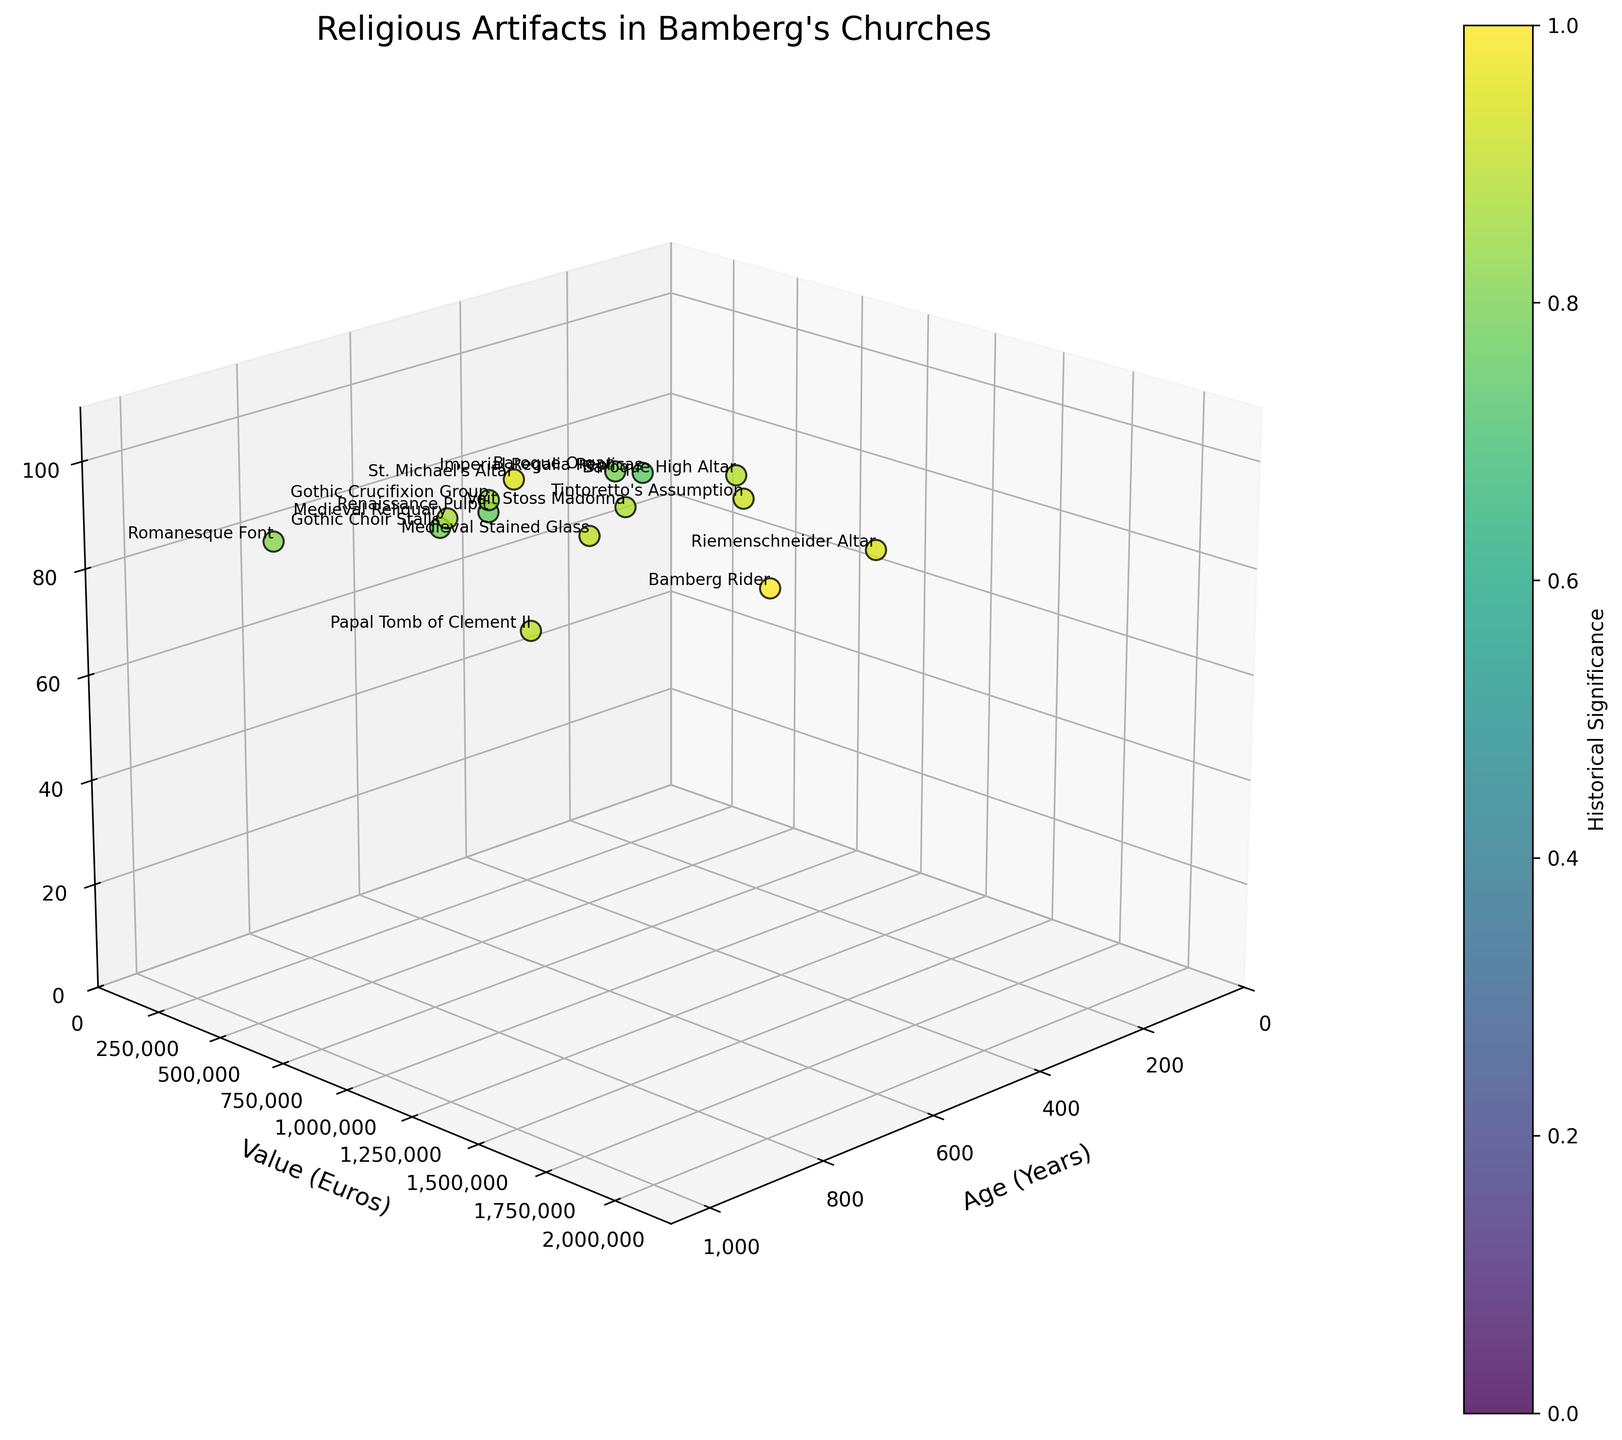what is the title of the figure? The title of the figure is displayed prominently at the top of the plot.
Answer: Religious Artifacts in Bamberg's Churches how many artifacts are displayed in the figure? To determine the number of artifacts, count the data points annotated with artifact names in the plot.
Answer: 15 which artifact is the oldest? Identify the artifact with the highest value on the 'Age (Years)' axis.
Answer: Papal Tomb of Clement II which artifact is the most valuable? Identify the artifact with the highest value on the 'Value (Euros)' axis.
Answer: Bamberg Rider which artifact has the highest historical significance? Find the artifact with the highest value on the 'Historical Significance' axis.
Answer: Bamberg Rider what is the range of ages displayed on the x-axis? The range can be found by looking at the minimum and maximum values on the 'Age (Years)' axis.
Answer: 200 to 970 years how does the monetary value of the Baroque High Altar compare to the Veit Stoss Madonna? Locate both artifacts on the 'Value (Euros)' axis and compare their values.
Answer: Baroque High Altar is less valuable than Veit Stoss Madonna which artifact is younger, the Renaissance Pulpit or the St. Michael's Altar? Compare the values of both artifacts on the 'Age (Years)' axis.
Answer: Renaissance Pulpit if you average the historical significance of the three most valuable artifacts, what is the result? Identify the three most valuable artifacts and average their historical significance ratings. Bamberg Rider (100) + Riemenschneider Altar (94) + Papal Tomb of Clement II (90) gives (100 + 94 + 90) / 3 = 94.67
Answer: 94.67 are there any artifacts older than 600 years but less valuable than 500,000 euros? Identify artifacts with 'Age (Years)' greater than 600 and 'Value (Euros)' less than 500,000.
Answer: None 